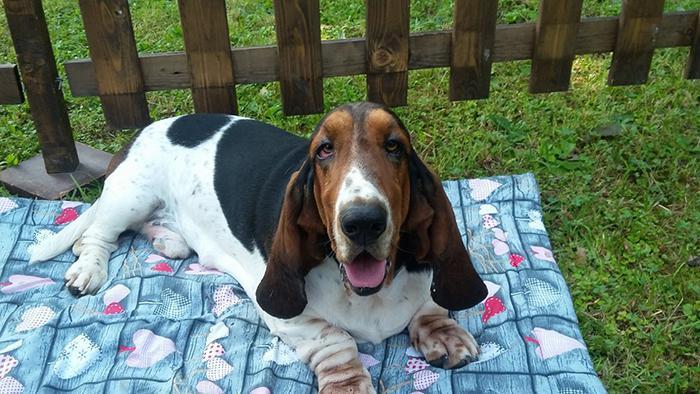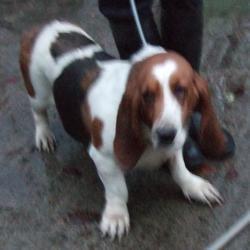The first image is the image on the left, the second image is the image on the right. Examine the images to the left and right. Is the description "The rightmost image features a single basset hound, on a leash, with no face of a person visible." accurate? Answer yes or no. Yes. The first image is the image on the left, the second image is the image on the right. Evaluate the accuracy of this statement regarding the images: "The dog in the right image is being held on a leash.". Is it true? Answer yes or no. Yes. 